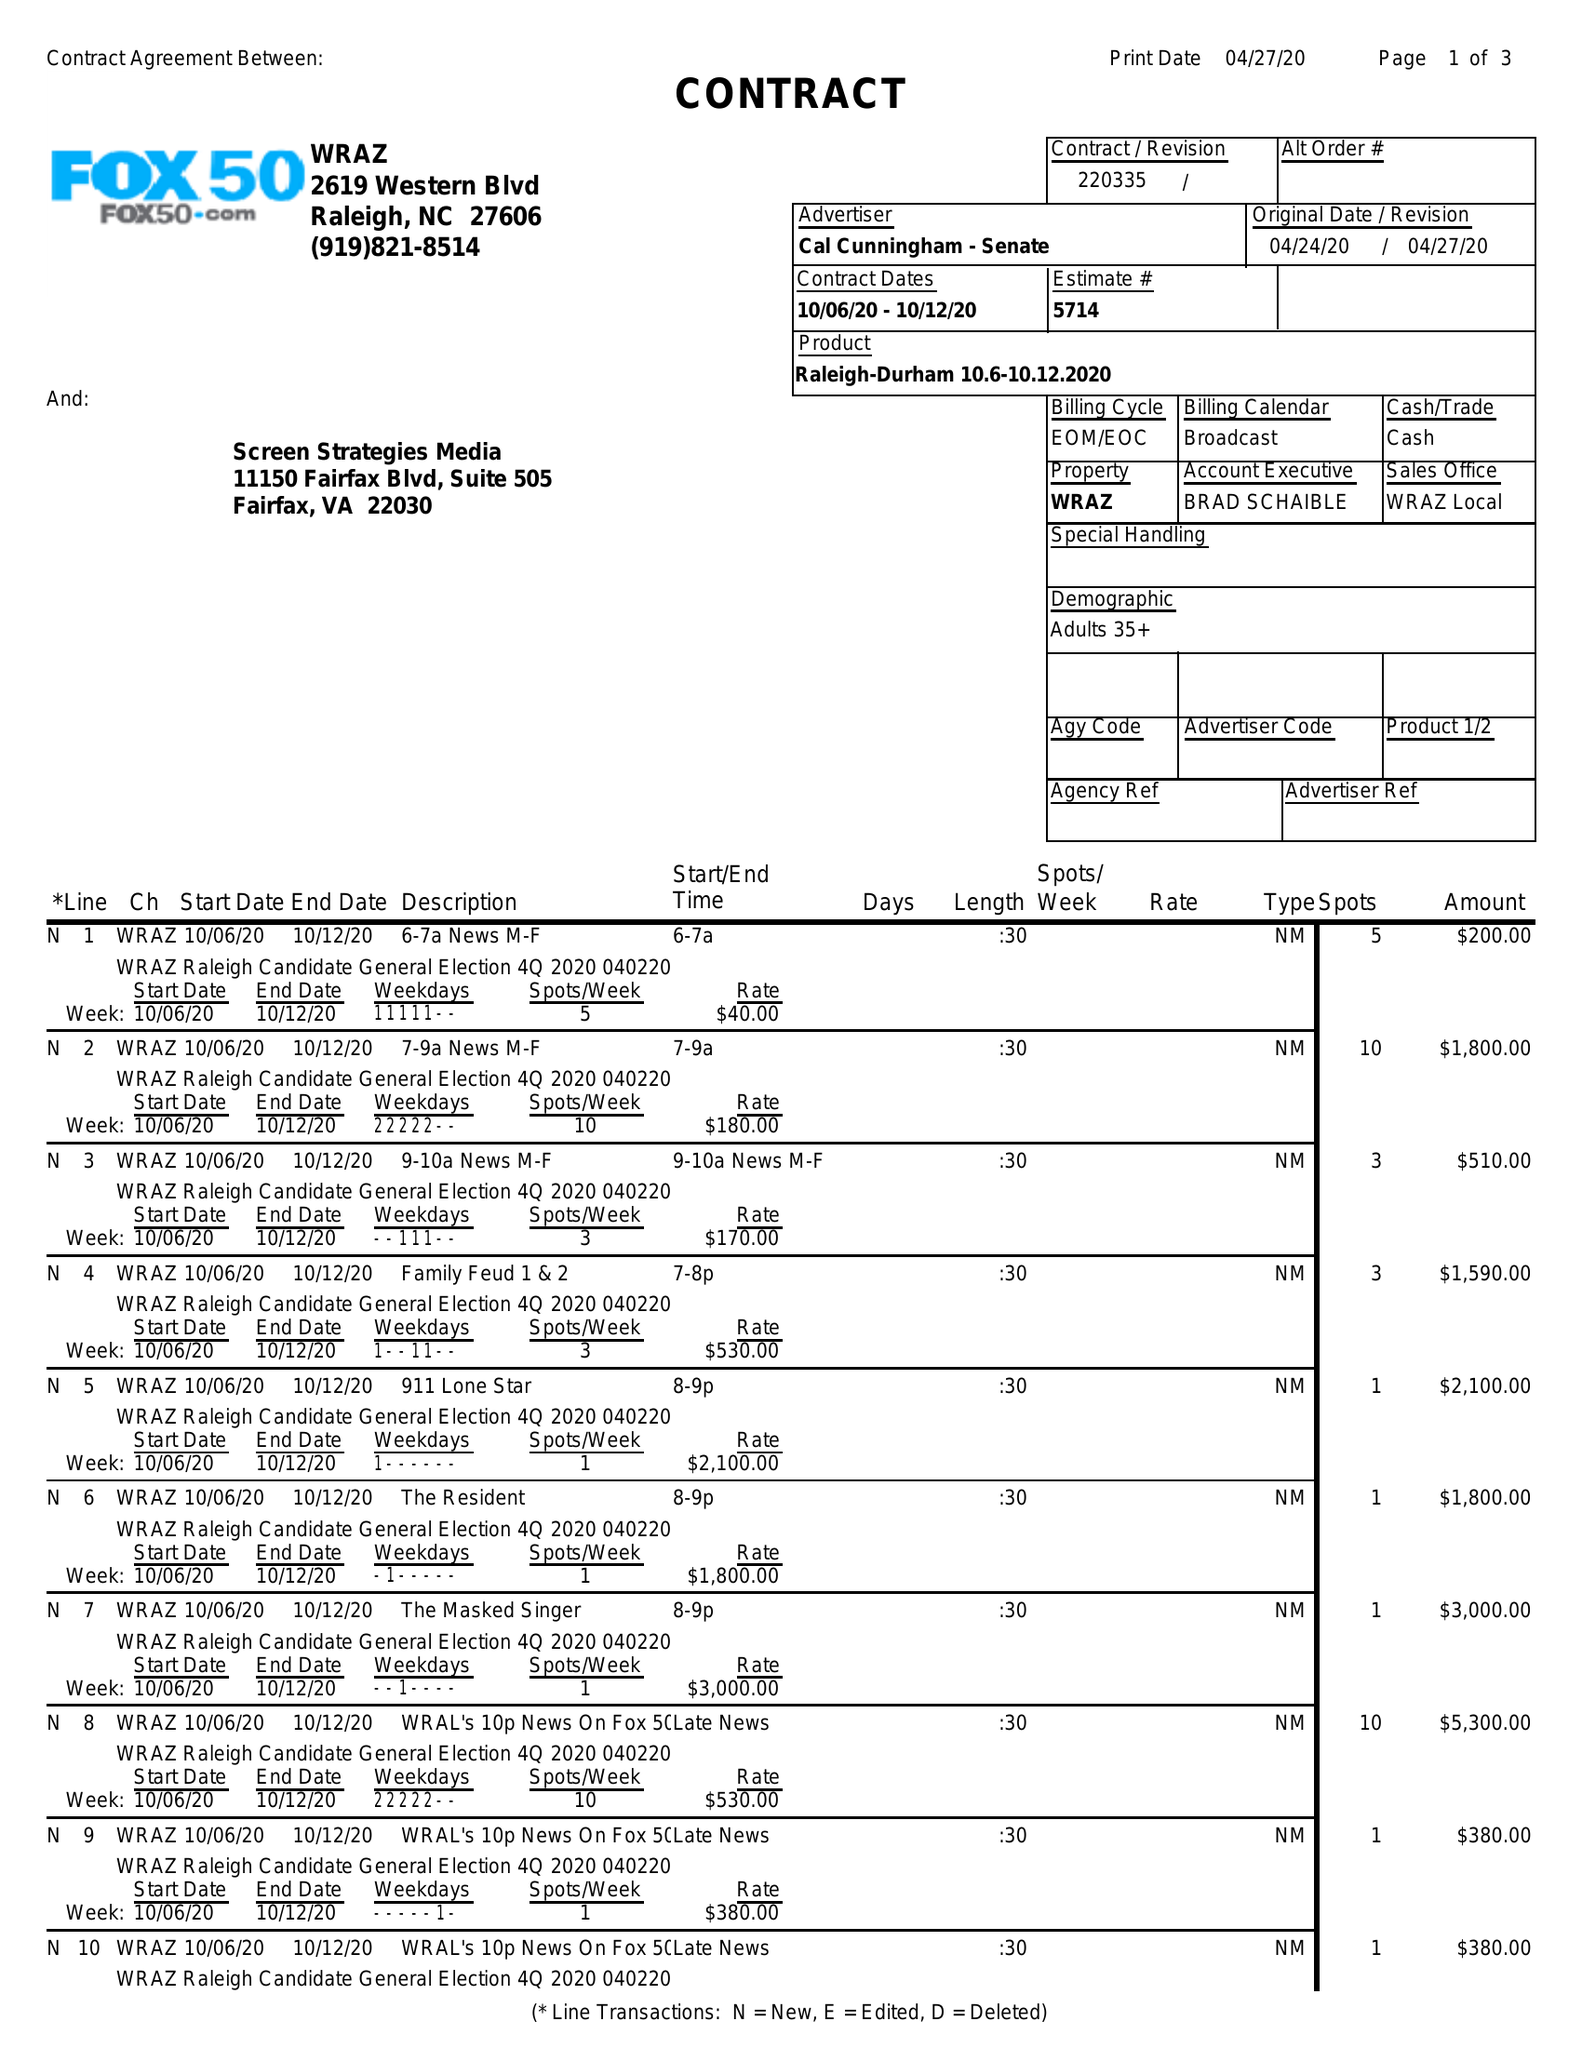What is the value for the contract_num?
Answer the question using a single word or phrase. 220335 